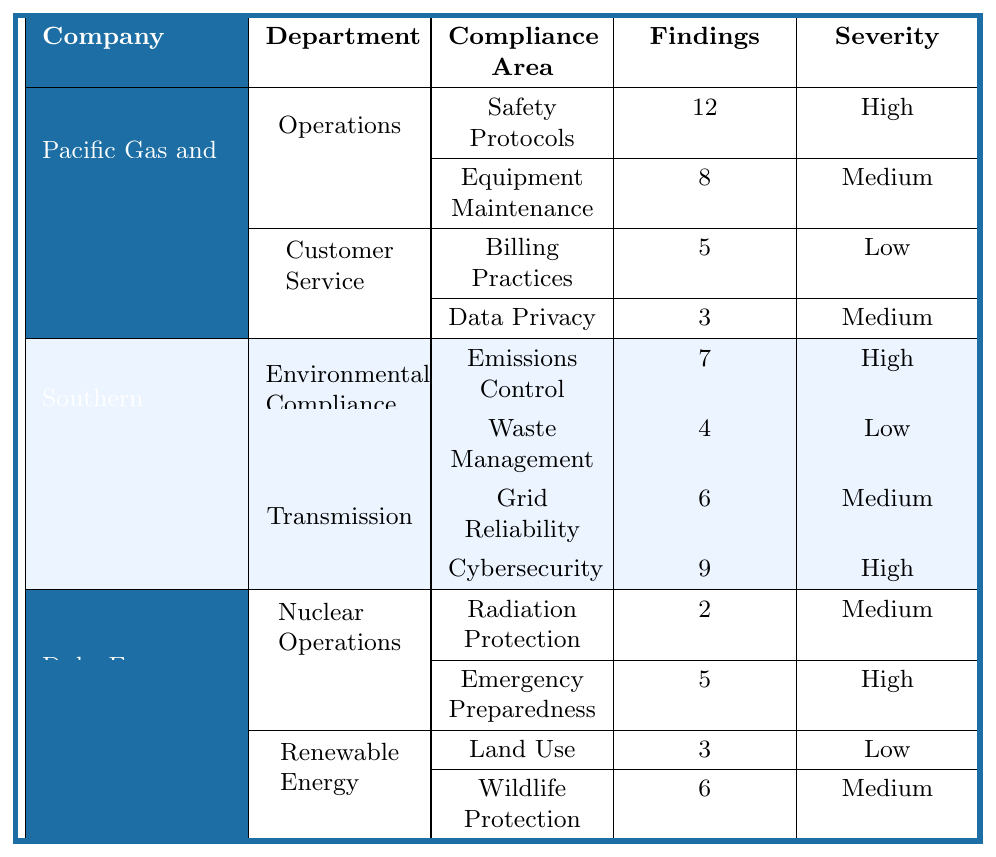What is the total number of findings reported for Pacific Gas and Electric (PG&E)? The findings for PG&E come from two departments: Operations (12 + 8 = 20) and Customer Service (5 + 3 = 8). Adding these results together gives a total of 20 + 8 = 28 findings.
Answer: 28 Which compliance area under Duke Energy has the highest severity? In Duke Energy, the compliance area with the highest severity is Emergency Preparedness under Nuclear Operations, which is classified as High.
Answer: Emergency Preparedness How many findings were reported for the Data Privacy area under Pacific Gas and Electric? The Data Privacy area under Pacific Gas and Electric has 3 findings, as reported in the Customer Service department.
Answer: 3 Is there any compliance area with a severity of Low for Southern California Edison? Yes, the Waste Management area under Environmental Compliance has a severity level classified as Low.
Answer: Yes What is the sum of findings for all compliance areas under Southern California Edison? The sum of findings for Southern California Edison includes Emissions Control (7) + Waste Management (4) + Grid Reliability (6) + Cybersecurity (9). Adding these gives 7 + 4 + 6 + 9 = 26.
Answer: 26 Which company has more total findings between PG&E and Duke Energy? PG&E has a total of 28 findings while Duke Energy has 2 + 5 + 3 + 6 = 16 findings. Comparing these totals, PG&E has more findings than Duke Energy.
Answer: PG&E How many compliance areas are reported with High severity across all companies? The areas with High severity are: Safety Protocols (PG&E), Emergency Preparedness (Duke Energy), Emissions Control (SCE), and Cybersecurity (SCE). There are a total of 4 compliance areas with High severity.
Answer: 4 What percentage of findings in the Operations department of PG&E are classified as High severity? In the Operations department of PG&E, there are 12 findings for Safety Protocols (High severity) and 8 for Equipment Maintenance (Medium severity), totaling 20 findings. The percentage of findings classified as High is (12 / 20) x 100 = 60%.
Answer: 60% What is the compliance area with the least number of findings at Duke Energy? The compliance area with the least number of findings at Duke Energy is Radiation Protection, which reports only 2 findings.
Answer: Radiation Protection Does Southern California Edison (SCE) have any findings in the Billing Practices area? No, Southern California Edison does not report any findings in the Billing Practices area; this area is reported under PG&E.
Answer: No 